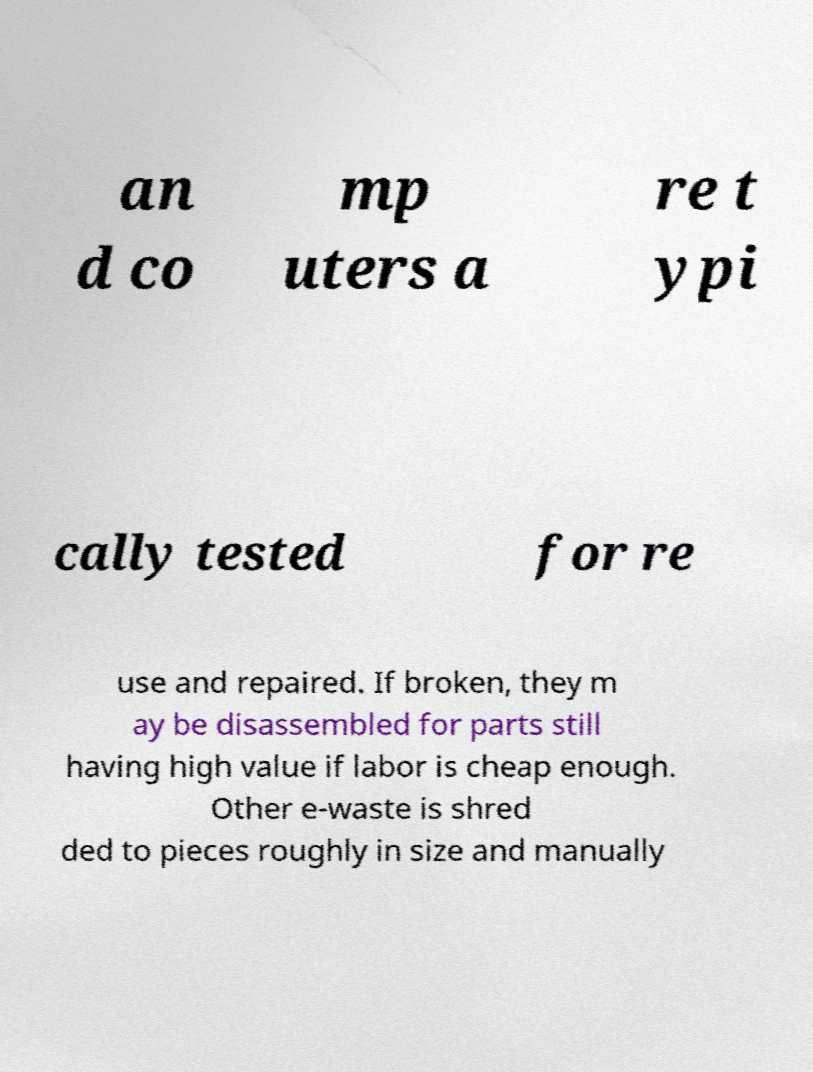I need the written content from this picture converted into text. Can you do that? an d co mp uters a re t ypi cally tested for re use and repaired. If broken, they m ay be disassembled for parts still having high value if labor is cheap enough. Other e-waste is shred ded to pieces roughly in size and manually 